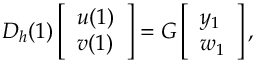Convert formula to latex. <formula><loc_0><loc_0><loc_500><loc_500>D _ { h } ( 1 ) \left [ \begin{array} { l } { u ( 1 ) } \\ { v ( 1 ) } \end{array} \right ] = G \left [ \begin{array} { l } { y _ { 1 } } \\ { w _ { 1 } } \end{array} \right ] ,</formula> 